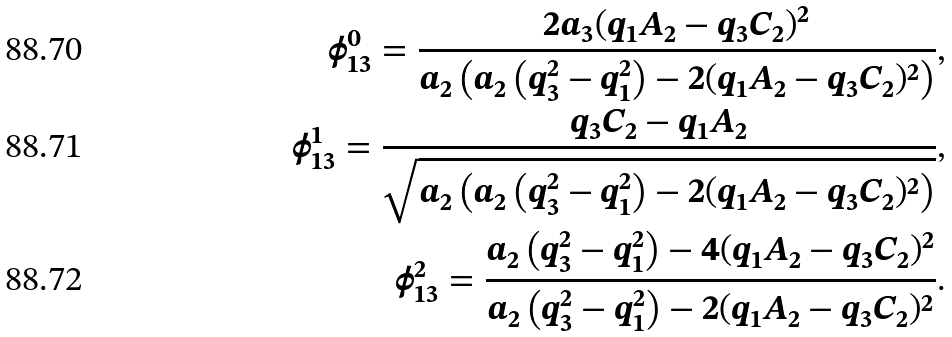Convert formula to latex. <formula><loc_0><loc_0><loc_500><loc_500>\phi _ { 1 3 } ^ { 0 } = \frac { 2 a _ { 3 } ( q _ { 1 } A _ { 2 } - q _ { 3 } C _ { 2 } ) ^ { 2 } } { a _ { 2 } \left ( a _ { 2 } \left ( q _ { 3 } ^ { 2 } - q _ { 1 } ^ { 2 } \right ) - 2 ( q _ { 1 } A _ { 2 } - q _ { 3 } C _ { 2 } ) ^ { 2 } \right ) } , \\ \phi _ { 1 3 } ^ { 1 } = \frac { q _ { 3 } C _ { 2 } - q _ { 1 } A _ { 2 } } { \sqrt { a _ { 2 } \left ( a _ { 2 } \left ( q _ { 3 } ^ { 2 } - q _ { 1 } ^ { 2 } \right ) - 2 ( q _ { 1 } A _ { 2 } - q _ { 3 } C _ { 2 } ) ^ { 2 } \right ) } } , \\ \phi _ { 1 3 } ^ { 2 } = \frac { a _ { 2 } \left ( q _ { 3 } ^ { 2 } - q _ { 1 } ^ { 2 } \right ) - 4 ( q _ { 1 } A _ { 2 } - q _ { 3 } C _ { 2 } ) ^ { 2 } } { a _ { 2 } \left ( q _ { 3 } ^ { 2 } - q _ { 1 } ^ { 2 } \right ) - 2 ( q _ { 1 } A _ { 2 } - q _ { 3 } C _ { 2 } ) ^ { 2 } } .</formula> 